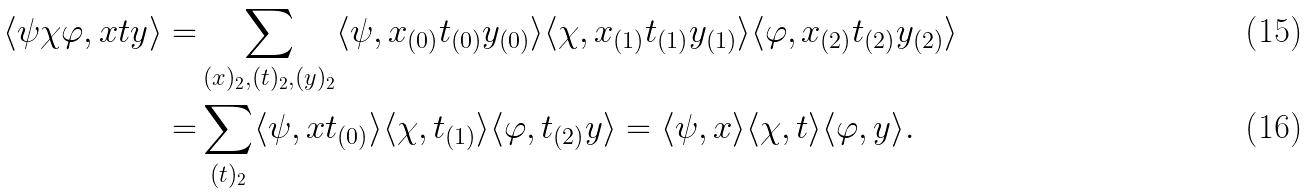<formula> <loc_0><loc_0><loc_500><loc_500>\langle \psi \chi \varphi , x t y \rangle = & \sum _ { ( x ) _ { 2 } , ( t ) _ { 2 } , ( y ) _ { 2 } } \langle \psi , x _ { ( 0 ) } t _ { ( 0 ) } y _ { ( 0 ) } \rangle \langle \chi , x _ { ( 1 ) } t _ { ( 1 ) } y _ { ( 1 ) } \rangle \langle \varphi , x _ { ( 2 ) } t _ { ( 2 ) } y _ { ( 2 ) } \rangle \\ = & \sum _ { ( t ) _ { 2 } } \langle \psi , x t _ { ( 0 ) } \rangle \langle \chi , t _ { ( 1 ) } \rangle \langle \varphi , t _ { ( 2 ) } y \rangle = \langle \psi , x \rangle \langle \chi , t \rangle \langle \varphi , y \rangle .</formula> 